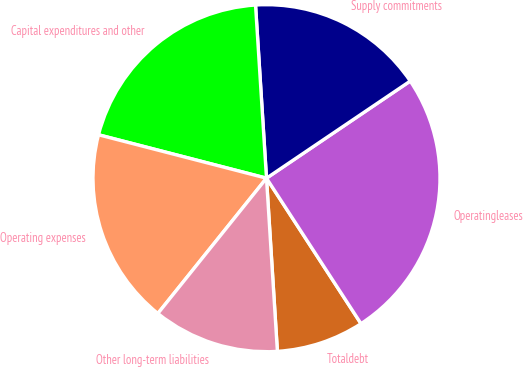<chart> <loc_0><loc_0><loc_500><loc_500><pie_chart><fcel>Totaldebt<fcel>Operatingleases<fcel>Supply commitments<fcel>Capital expenditures and other<fcel>Operating expenses<fcel>Other long-term liabilities<nl><fcel>8.17%<fcel>25.29%<fcel>16.55%<fcel>19.97%<fcel>18.26%<fcel>11.77%<nl></chart> 